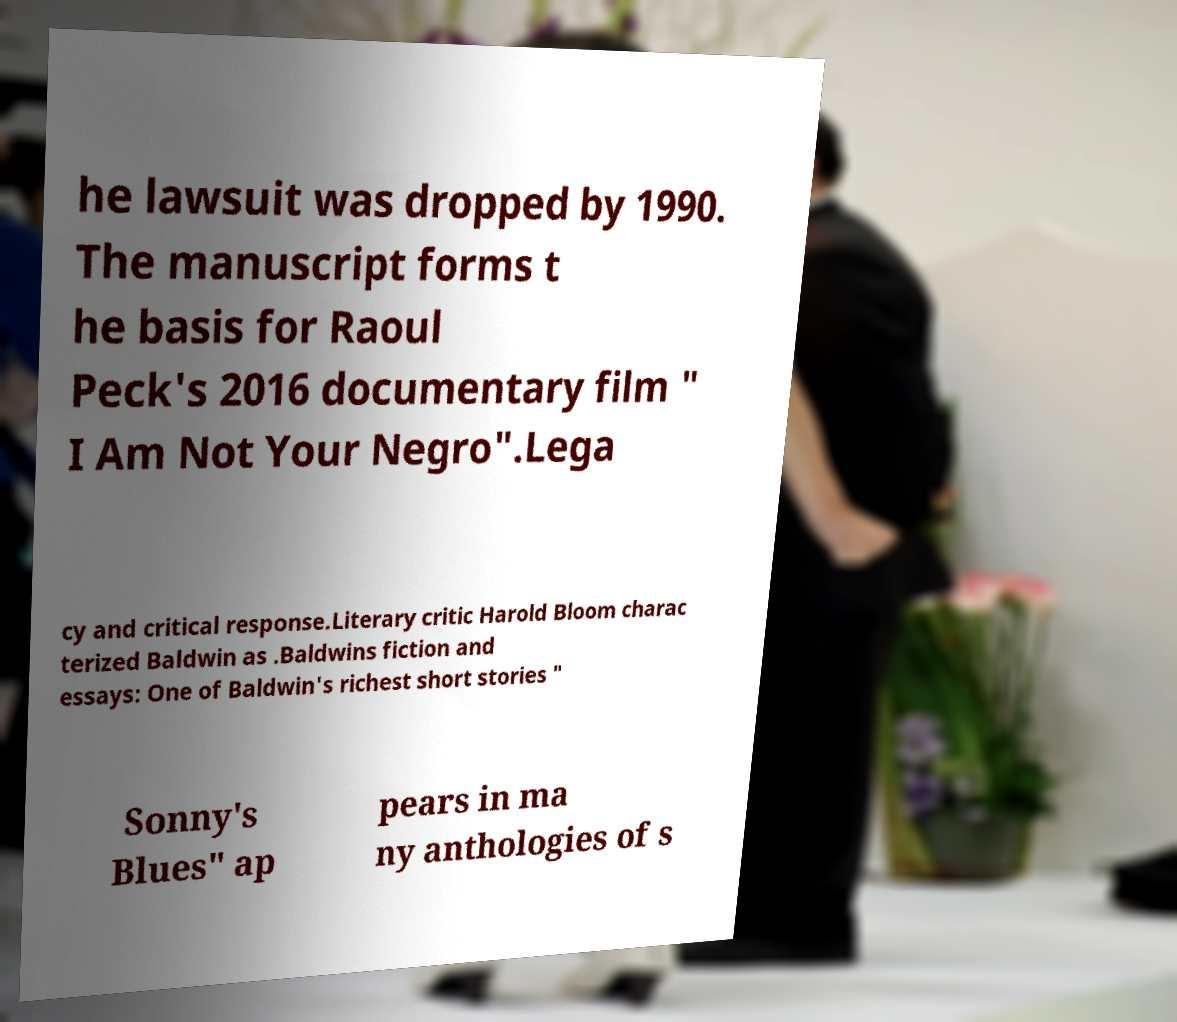Could you extract and type out the text from this image? he lawsuit was dropped by 1990. The manuscript forms t he basis for Raoul Peck's 2016 documentary film " I Am Not Your Negro".Lega cy and critical response.Literary critic Harold Bloom charac terized Baldwin as .Baldwins fiction and essays: One of Baldwin's richest short stories " Sonny's Blues" ap pears in ma ny anthologies of s 